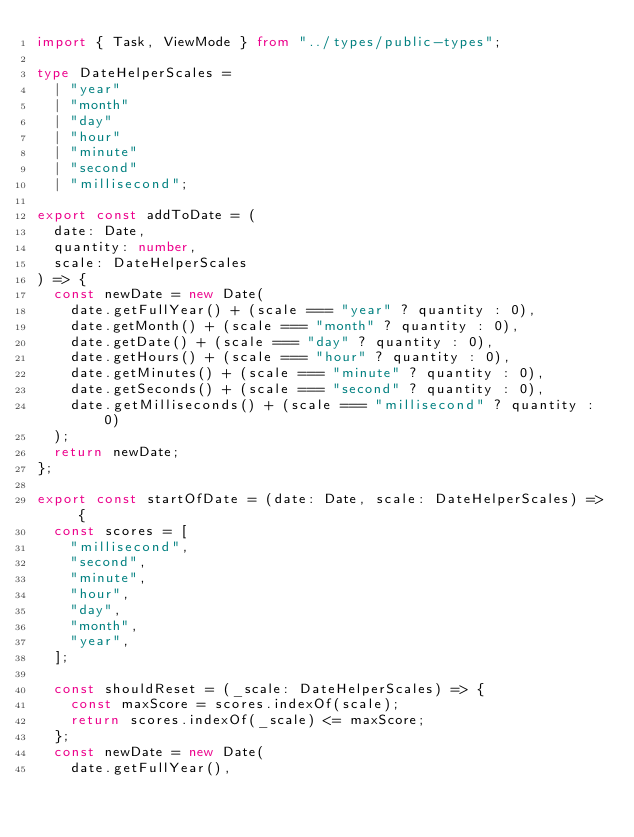<code> <loc_0><loc_0><loc_500><loc_500><_TypeScript_>import { Task, ViewMode } from "../types/public-types";

type DateHelperScales =
  | "year"
  | "month"
  | "day"
  | "hour"
  | "minute"
  | "second"
  | "millisecond";

export const addToDate = (
  date: Date,
  quantity: number,
  scale: DateHelperScales
) => {
  const newDate = new Date(
    date.getFullYear() + (scale === "year" ? quantity : 0),
    date.getMonth() + (scale === "month" ? quantity : 0),
    date.getDate() + (scale === "day" ? quantity : 0),
    date.getHours() + (scale === "hour" ? quantity : 0),
    date.getMinutes() + (scale === "minute" ? quantity : 0),
    date.getSeconds() + (scale === "second" ? quantity : 0),
    date.getMilliseconds() + (scale === "millisecond" ? quantity : 0)
  );
  return newDate;
};

export const startOfDate = (date: Date, scale: DateHelperScales) => {
  const scores = [
    "millisecond",
    "second",
    "minute",
    "hour",
    "day",
    "month",
    "year",
  ];

  const shouldReset = (_scale: DateHelperScales) => {
    const maxScore = scores.indexOf(scale);
    return scores.indexOf(_scale) <= maxScore;
  };
  const newDate = new Date(
    date.getFullYear(),</code> 